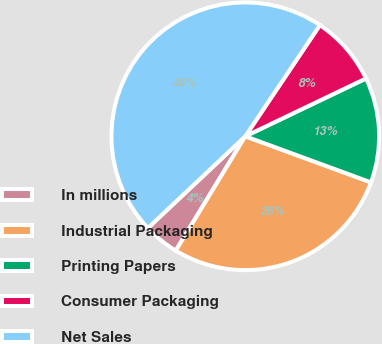<chart> <loc_0><loc_0><loc_500><loc_500><pie_chart><fcel>In millions<fcel>Industrial Packaging<fcel>Printing Papers<fcel>Consumer Packaging<fcel>Net Sales<nl><fcel>4.28%<fcel>28.1%<fcel>12.71%<fcel>8.49%<fcel>46.43%<nl></chart> 